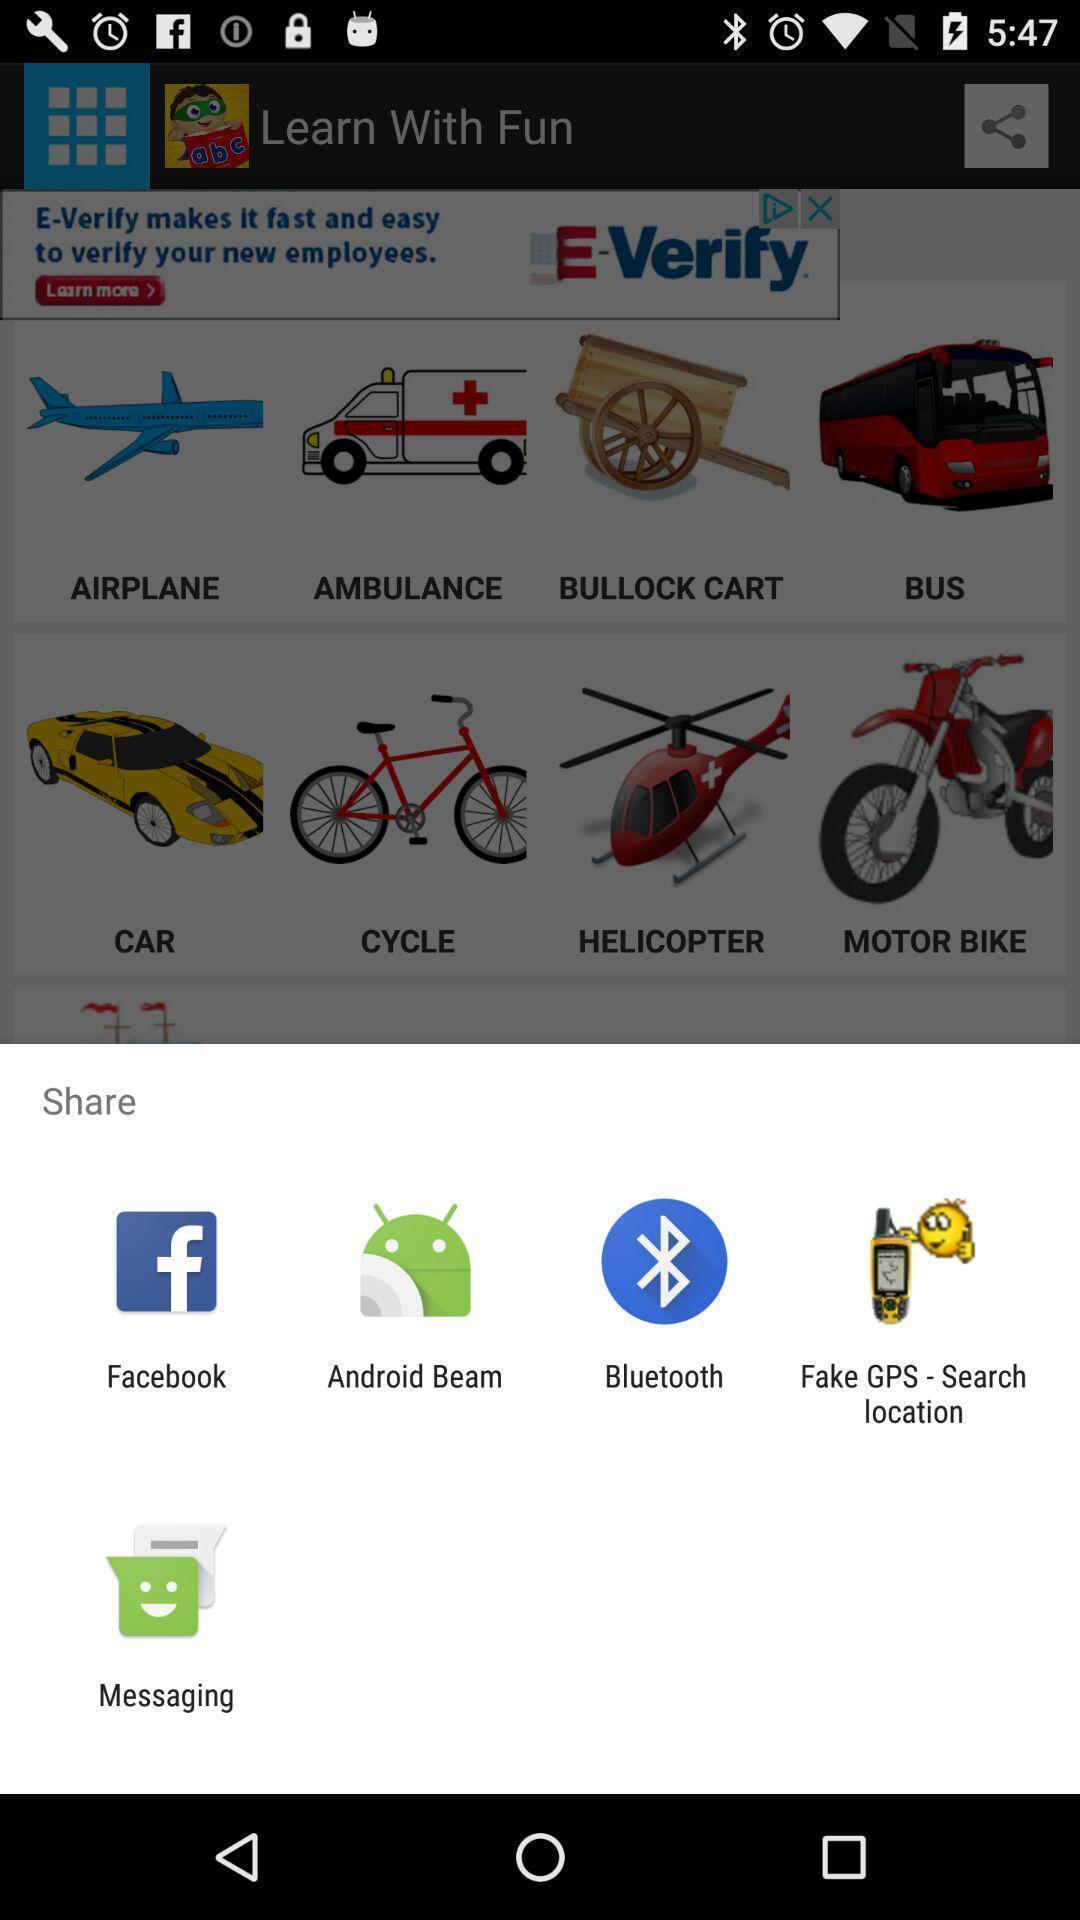Summarize the information in this screenshot. Pop-up with different options for sharing a link. 